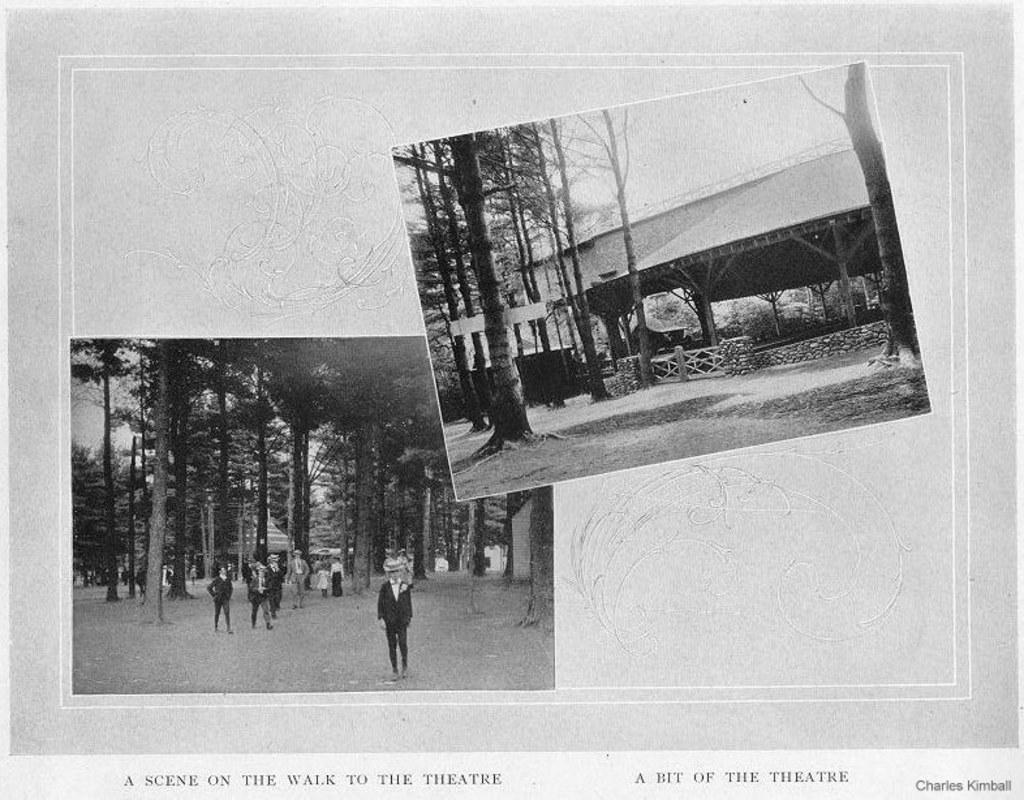How many photo frames are visible in the image? There are two photo frames in the image. What types of images are contained within the photo frames? The photo frames contain images of a crowd, trees, a shed, a fence, and the sky. What can be inferred about the time of day the image was taken? The image appears to be taken during the day, as the sky is visible. Where is the father standing in the image? There is no father present in the image; it only contains photo frames with various images. What type of bucket can be seen in the image? There is no bucket present in the image. Is there a fan visible in the image? There is no fan present in the image. 